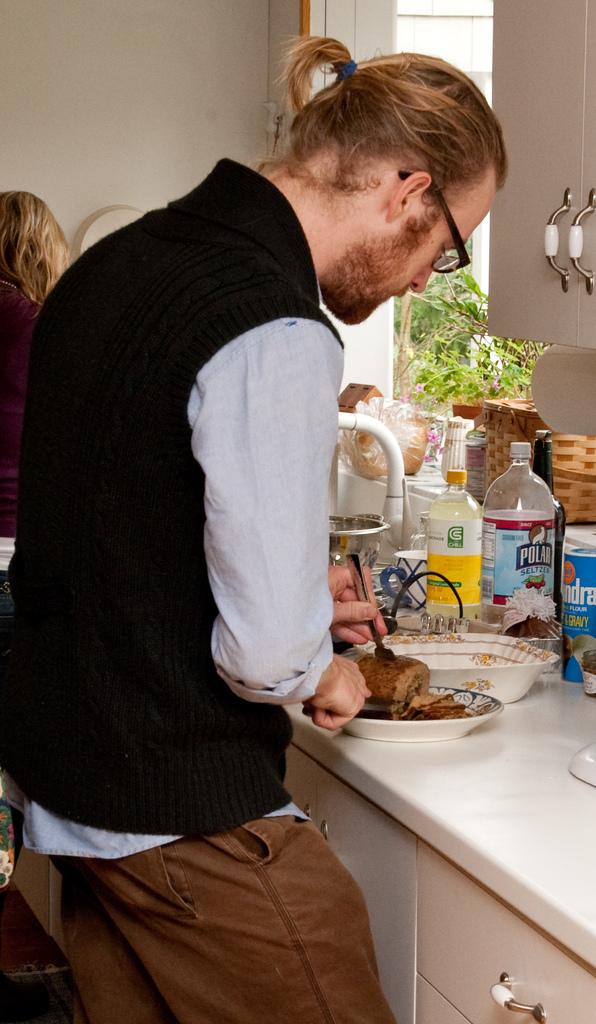What is the brand of the seltzer?
Give a very brief answer. Polar. What product is the brand polar selling?
Make the answer very short. Unanswerable. 